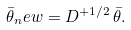Convert formula to latex. <formula><loc_0><loc_0><loc_500><loc_500>\bar { \theta } _ { n } e w = D ^ { + 1 / 2 } \, \bar { \theta } .</formula> 